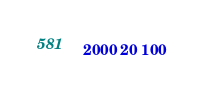Convert code to text. <code><loc_0><loc_0><loc_500><loc_500><_Java_>2000 20 100</code> 